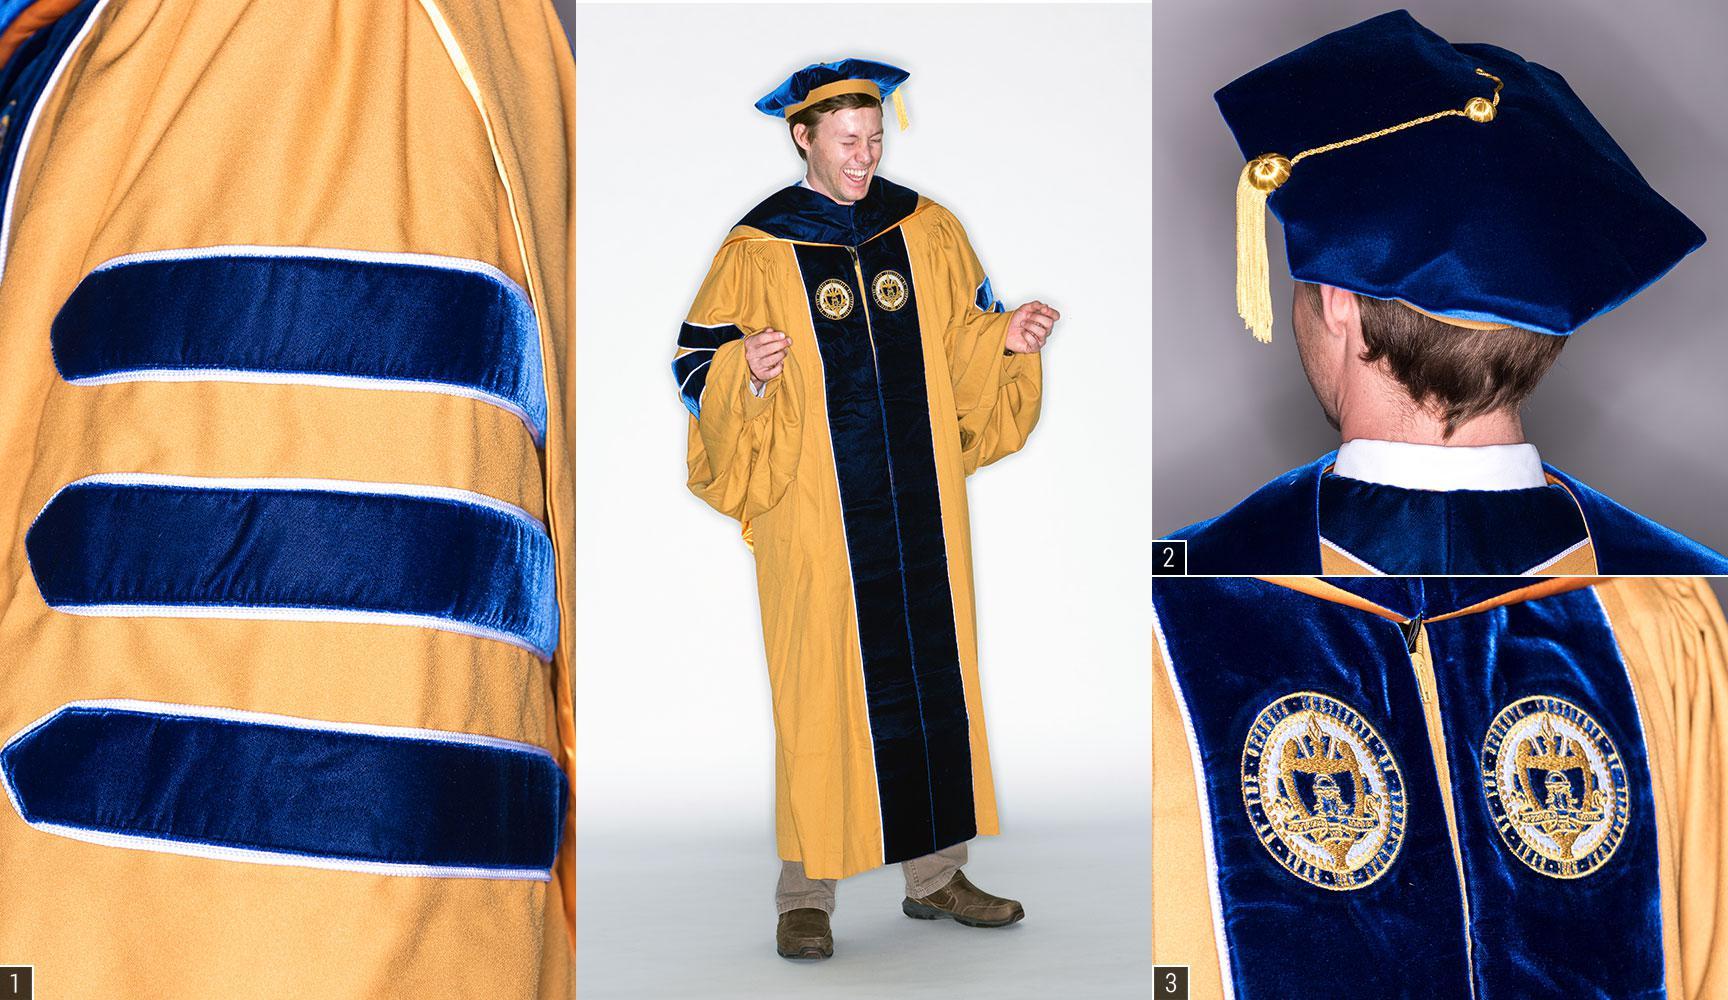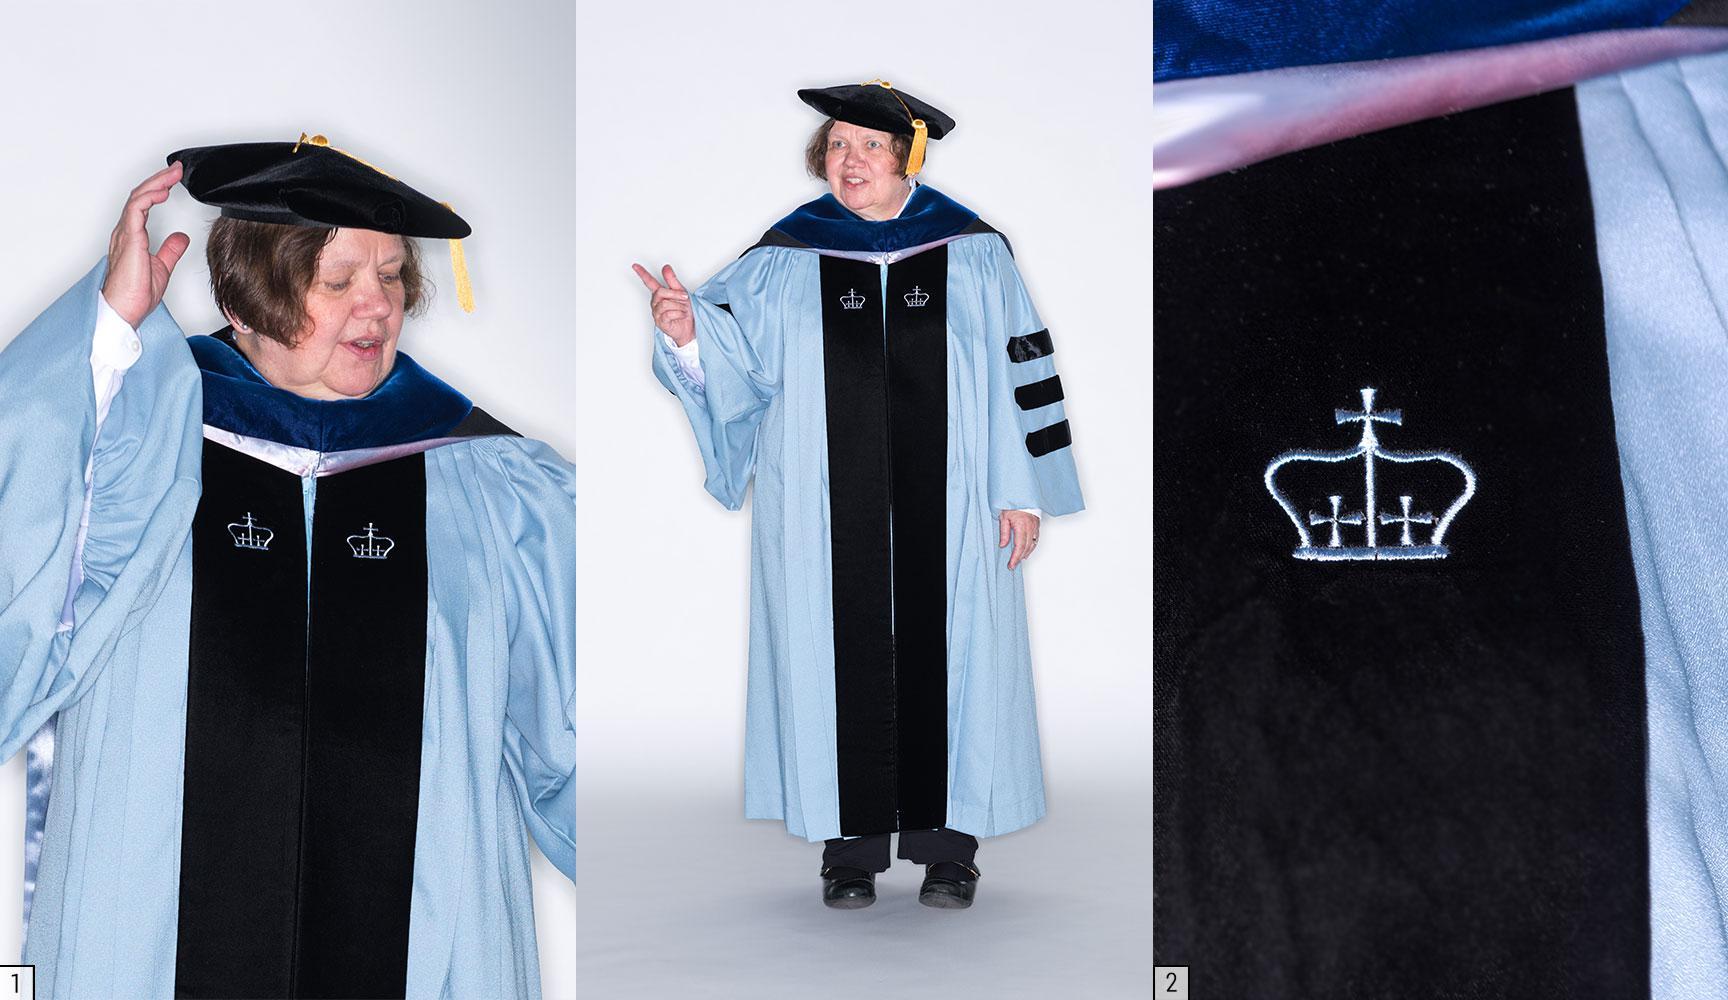The first image is the image on the left, the second image is the image on the right. For the images shown, is this caption "There is a single male with a blue and grey gown on in one image." true? Answer yes or no. No. The first image is the image on the left, the second image is the image on the right. For the images displayed, is the sentence "There is one guy in the left image, wearing a black robe with blue stripes on the sleeve." factually correct? Answer yes or no. No. 